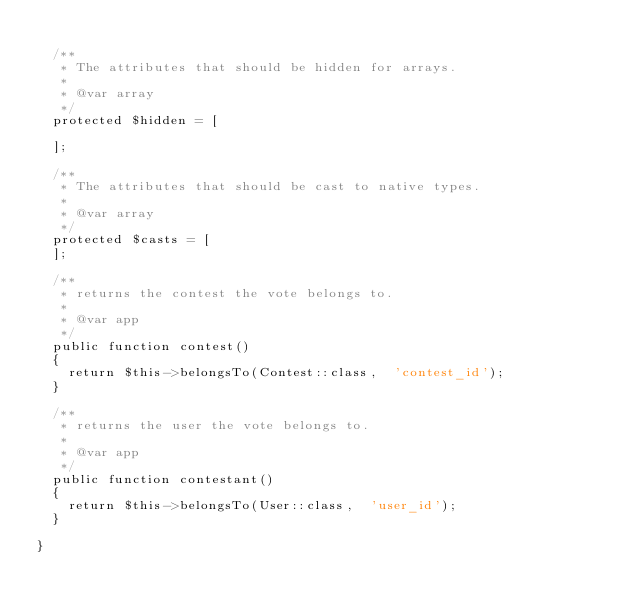<code> <loc_0><loc_0><loc_500><loc_500><_PHP_>
  /**
   * The attributes that should be hidden for arrays.
   *
   * @var array
   */
  protected $hidden = [

  ];

  /**
   * The attributes that should be cast to native types.
   *
   * @var array
   */
  protected $casts = [
  ];

  /**
   * returns the contest the vote belongs to.
   *
   * @var app
   */
  public function contest()
  {
    return $this->belongsTo(Contest::class,  'contest_id');
  }

  /**
   * returns the user the vote belongs to.
   *
   * @var app
   */
  public function contestant()
  {
    return $this->belongsTo(User::class,  'user_id');
  }

}
</code> 